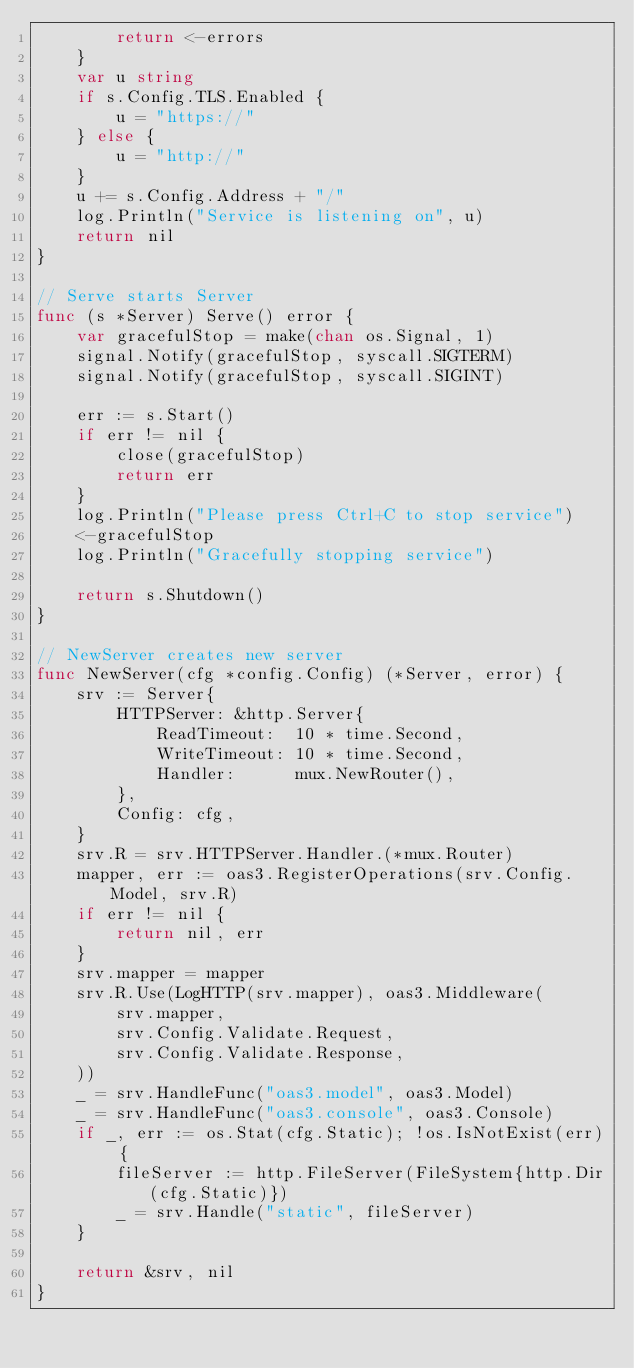<code> <loc_0><loc_0><loc_500><loc_500><_Go_>		return <-errors
	}
	var u string
	if s.Config.TLS.Enabled {
		u = "https://"
	} else {
		u = "http://"
	}
	u += s.Config.Address + "/"
	log.Println("Service is listening on", u)
	return nil
}

// Serve starts Server
func (s *Server) Serve() error {
	var gracefulStop = make(chan os.Signal, 1)
	signal.Notify(gracefulStop, syscall.SIGTERM)
	signal.Notify(gracefulStop, syscall.SIGINT)

	err := s.Start()
	if err != nil {
		close(gracefulStop)
		return err
	}
	log.Println("Please press Ctrl+C to stop service")
	<-gracefulStop
	log.Println("Gracefully stopping service")

	return s.Shutdown()
}

// NewServer creates new server
func NewServer(cfg *config.Config) (*Server, error) {
	srv := Server{
		HTTPServer: &http.Server{
			ReadTimeout:  10 * time.Second,
			WriteTimeout: 10 * time.Second,
			Handler:      mux.NewRouter(),
		},
		Config: cfg,
	}
	srv.R = srv.HTTPServer.Handler.(*mux.Router)
	mapper, err := oas3.RegisterOperations(srv.Config.Model, srv.R)
	if err != nil {
		return nil, err
	}
	srv.mapper = mapper
	srv.R.Use(LogHTTP(srv.mapper), oas3.Middleware(
		srv.mapper,
		srv.Config.Validate.Request,
		srv.Config.Validate.Response,
	))
	_ = srv.HandleFunc("oas3.model", oas3.Model)
	_ = srv.HandleFunc("oas3.console", oas3.Console)
	if _, err := os.Stat(cfg.Static); !os.IsNotExist(err) {
		fileServer := http.FileServer(FileSystem{http.Dir(cfg.Static)})
		_ = srv.Handle("static", fileServer)
	}

	return &srv, nil
}
</code> 